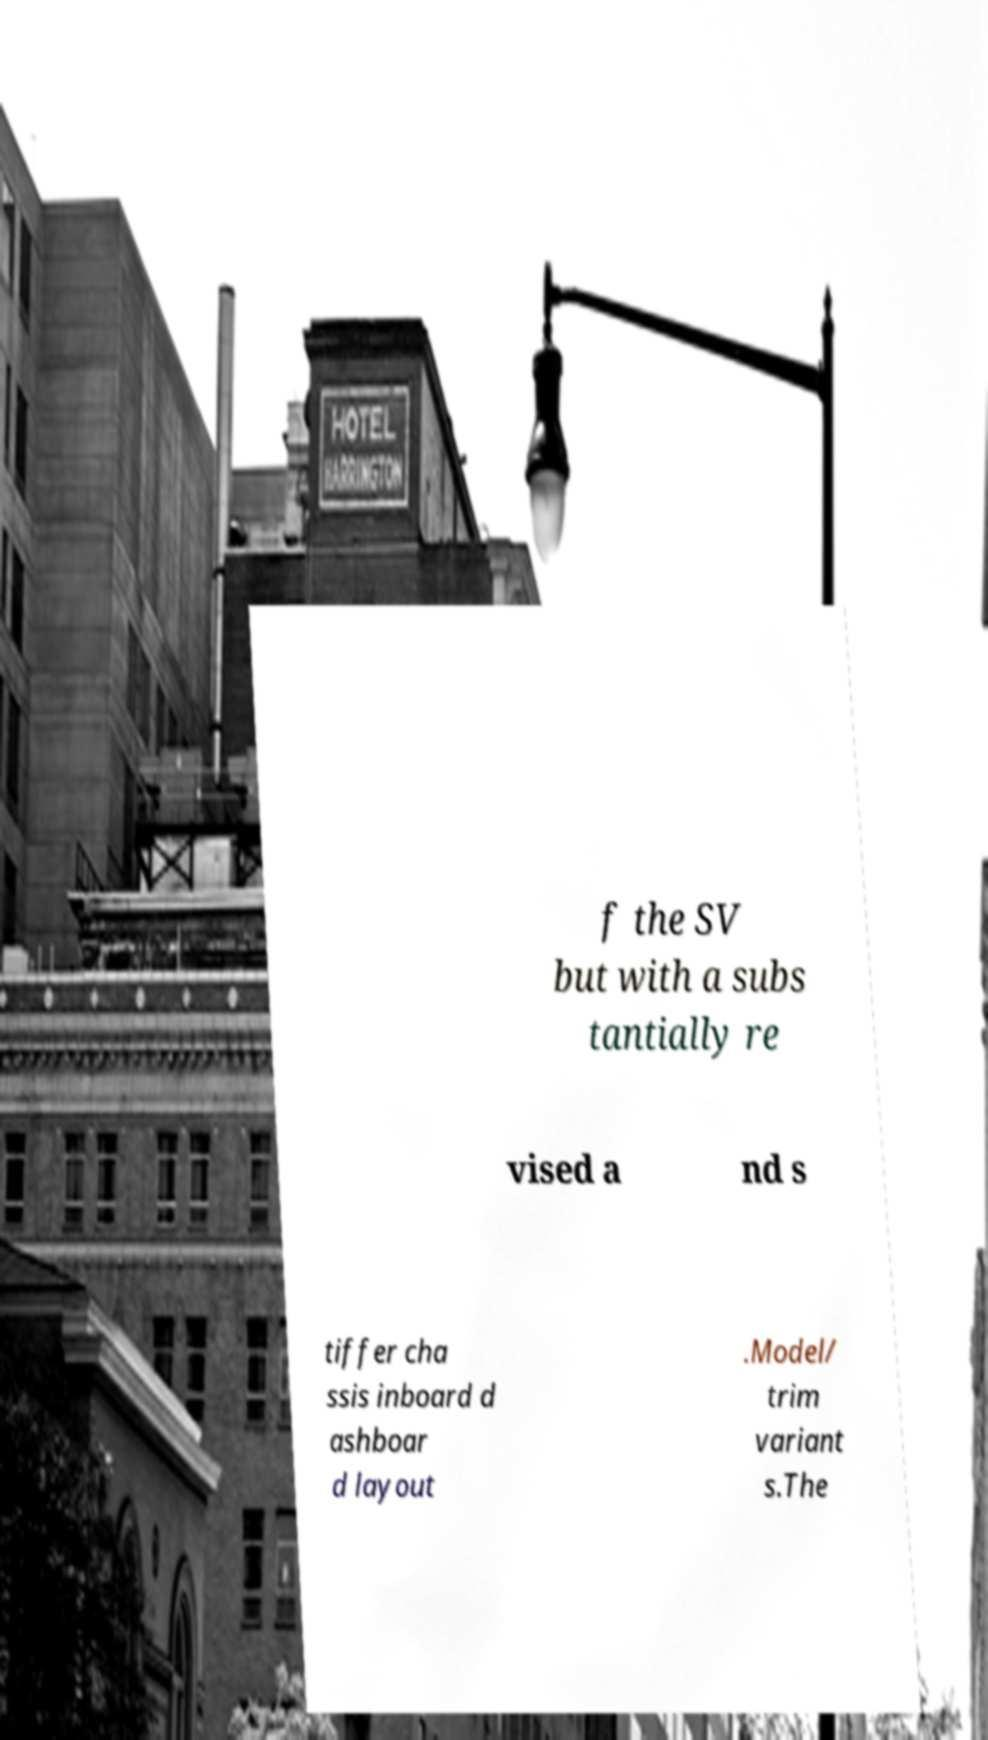Can you accurately transcribe the text from the provided image for me? f the SV but with a subs tantially re vised a nd s tiffer cha ssis inboard d ashboar d layout .Model/ trim variant s.The 